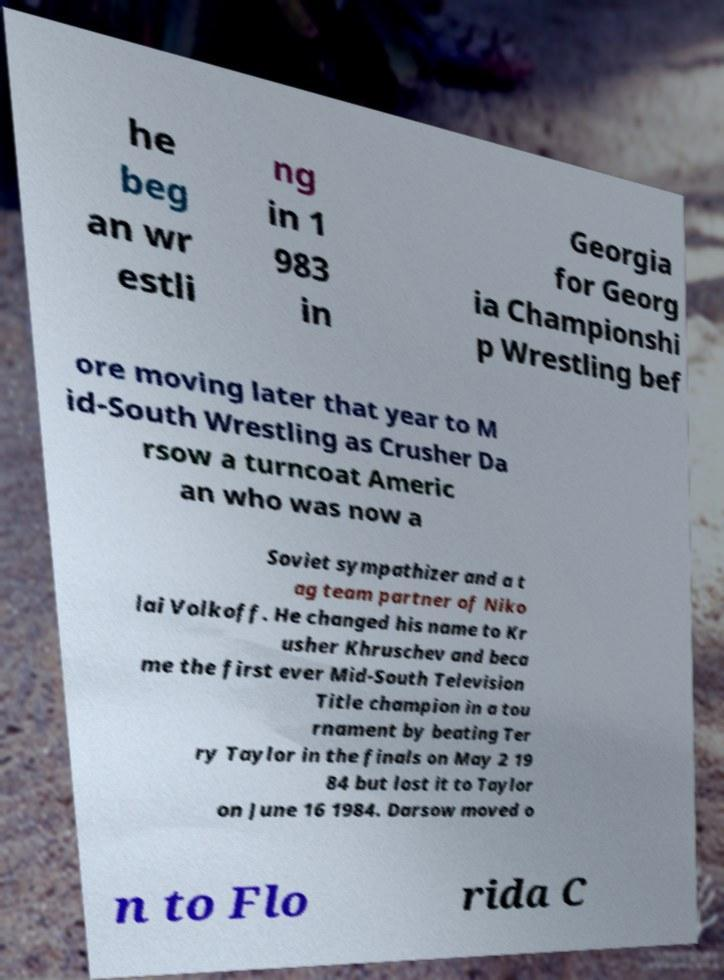Can you accurately transcribe the text from the provided image for me? he beg an wr estli ng in 1 983 in Georgia for Georg ia Championshi p Wrestling bef ore moving later that year to M id-South Wrestling as Crusher Da rsow a turncoat Americ an who was now a Soviet sympathizer and a t ag team partner of Niko lai Volkoff. He changed his name to Kr usher Khruschev and beca me the first ever Mid-South Television Title champion in a tou rnament by beating Ter ry Taylor in the finals on May 2 19 84 but lost it to Taylor on June 16 1984. Darsow moved o n to Flo rida C 